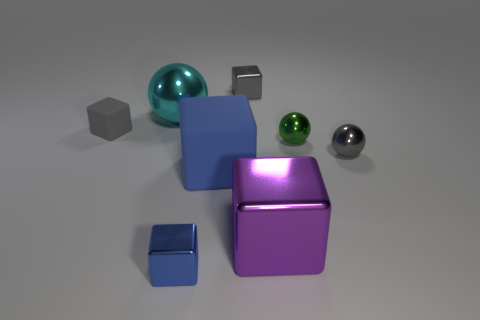Subtract all purple blocks. How many blocks are left? 4 Subtract all small gray metallic blocks. How many blocks are left? 4 Subtract all cyan blocks. Subtract all brown cylinders. How many blocks are left? 5 Add 1 large matte blocks. How many objects exist? 9 Subtract all cubes. How many objects are left? 3 Add 8 purple metal things. How many purple metal things are left? 9 Add 4 small green balls. How many small green balls exist? 5 Subtract 0 cyan blocks. How many objects are left? 8 Subtract all tiny blue shiny objects. Subtract all green metal spheres. How many objects are left? 6 